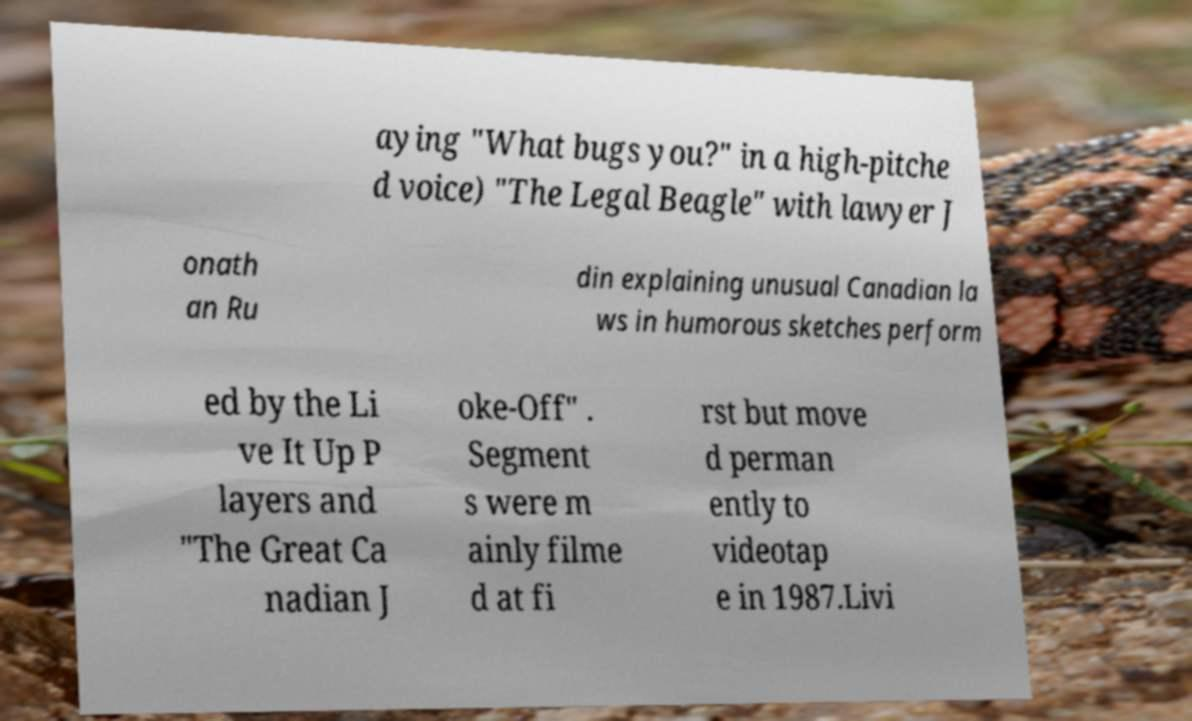Can you read and provide the text displayed in the image?This photo seems to have some interesting text. Can you extract and type it out for me? aying "What bugs you?" in a high-pitche d voice) "The Legal Beagle" with lawyer J onath an Ru din explaining unusual Canadian la ws in humorous sketches perform ed by the Li ve It Up P layers and "The Great Ca nadian J oke-Off" . Segment s were m ainly filme d at fi rst but move d perman ently to videotap e in 1987.Livi 